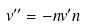<formula> <loc_0><loc_0><loc_500><loc_500>v ^ { \prime \prime } = - n v ^ { \prime } n</formula> 